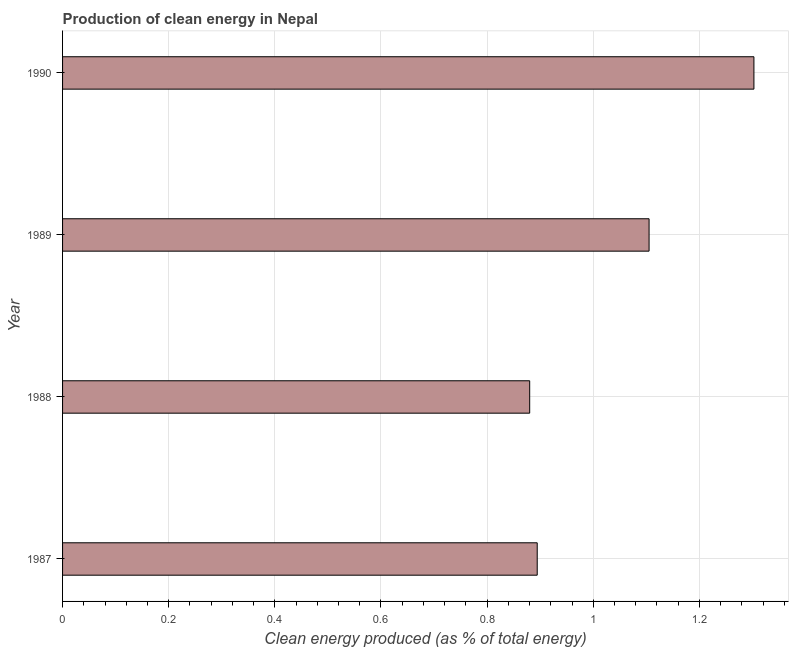Does the graph contain any zero values?
Your answer should be very brief. No. What is the title of the graph?
Your answer should be very brief. Production of clean energy in Nepal. What is the label or title of the X-axis?
Ensure brevity in your answer.  Clean energy produced (as % of total energy). What is the label or title of the Y-axis?
Provide a short and direct response. Year. What is the production of clean energy in 1987?
Your answer should be compact. 0.89. Across all years, what is the maximum production of clean energy?
Ensure brevity in your answer.  1.3. Across all years, what is the minimum production of clean energy?
Give a very brief answer. 0.88. In which year was the production of clean energy maximum?
Keep it short and to the point. 1990. In which year was the production of clean energy minimum?
Offer a terse response. 1988. What is the sum of the production of clean energy?
Ensure brevity in your answer.  4.18. What is the difference between the production of clean energy in 1987 and 1988?
Provide a succinct answer. 0.01. What is the average production of clean energy per year?
Provide a short and direct response. 1.05. What is the median production of clean energy?
Your answer should be compact. 1. In how many years, is the production of clean energy greater than 0.36 %?
Offer a very short reply. 4. What is the ratio of the production of clean energy in 1989 to that in 1990?
Your answer should be very brief. 0.85. What is the difference between the highest and the second highest production of clean energy?
Give a very brief answer. 0.2. Is the sum of the production of clean energy in 1987 and 1990 greater than the maximum production of clean energy across all years?
Provide a succinct answer. Yes. What is the difference between the highest and the lowest production of clean energy?
Give a very brief answer. 0.42. Are all the bars in the graph horizontal?
Keep it short and to the point. Yes. What is the difference between two consecutive major ticks on the X-axis?
Offer a very short reply. 0.2. What is the Clean energy produced (as % of total energy) in 1987?
Provide a short and direct response. 0.89. What is the Clean energy produced (as % of total energy) in 1988?
Keep it short and to the point. 0.88. What is the Clean energy produced (as % of total energy) of 1989?
Give a very brief answer. 1.11. What is the Clean energy produced (as % of total energy) in 1990?
Provide a short and direct response. 1.3. What is the difference between the Clean energy produced (as % of total energy) in 1987 and 1988?
Give a very brief answer. 0.01. What is the difference between the Clean energy produced (as % of total energy) in 1987 and 1989?
Make the answer very short. -0.21. What is the difference between the Clean energy produced (as % of total energy) in 1987 and 1990?
Your answer should be very brief. -0.41. What is the difference between the Clean energy produced (as % of total energy) in 1988 and 1989?
Ensure brevity in your answer.  -0.22. What is the difference between the Clean energy produced (as % of total energy) in 1988 and 1990?
Keep it short and to the point. -0.42. What is the difference between the Clean energy produced (as % of total energy) in 1989 and 1990?
Offer a very short reply. -0.2. What is the ratio of the Clean energy produced (as % of total energy) in 1987 to that in 1989?
Keep it short and to the point. 0.81. What is the ratio of the Clean energy produced (as % of total energy) in 1987 to that in 1990?
Give a very brief answer. 0.69. What is the ratio of the Clean energy produced (as % of total energy) in 1988 to that in 1989?
Give a very brief answer. 0.8. What is the ratio of the Clean energy produced (as % of total energy) in 1988 to that in 1990?
Provide a succinct answer. 0.68. What is the ratio of the Clean energy produced (as % of total energy) in 1989 to that in 1990?
Offer a very short reply. 0.85. 